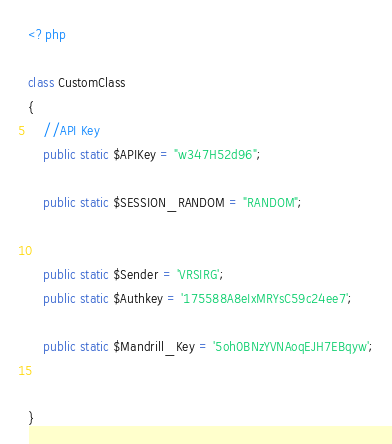Convert code to text. <code><loc_0><loc_0><loc_500><loc_500><_PHP_><?php

class CustomClass
{
    //API Key
    public static $APIKey = "w347H52d96";   
    
    public static $SESSION_RANDOM = "RANDOM";

    
    public static $Sender = 'VRSIRG';
    public static $Authkey = '175588A8eIxMRYsC59c24ee7';

    public static $Mandrill_Key = '5oh0BNzYVNAoqEJH7EBqyw';
    

}


</code> 